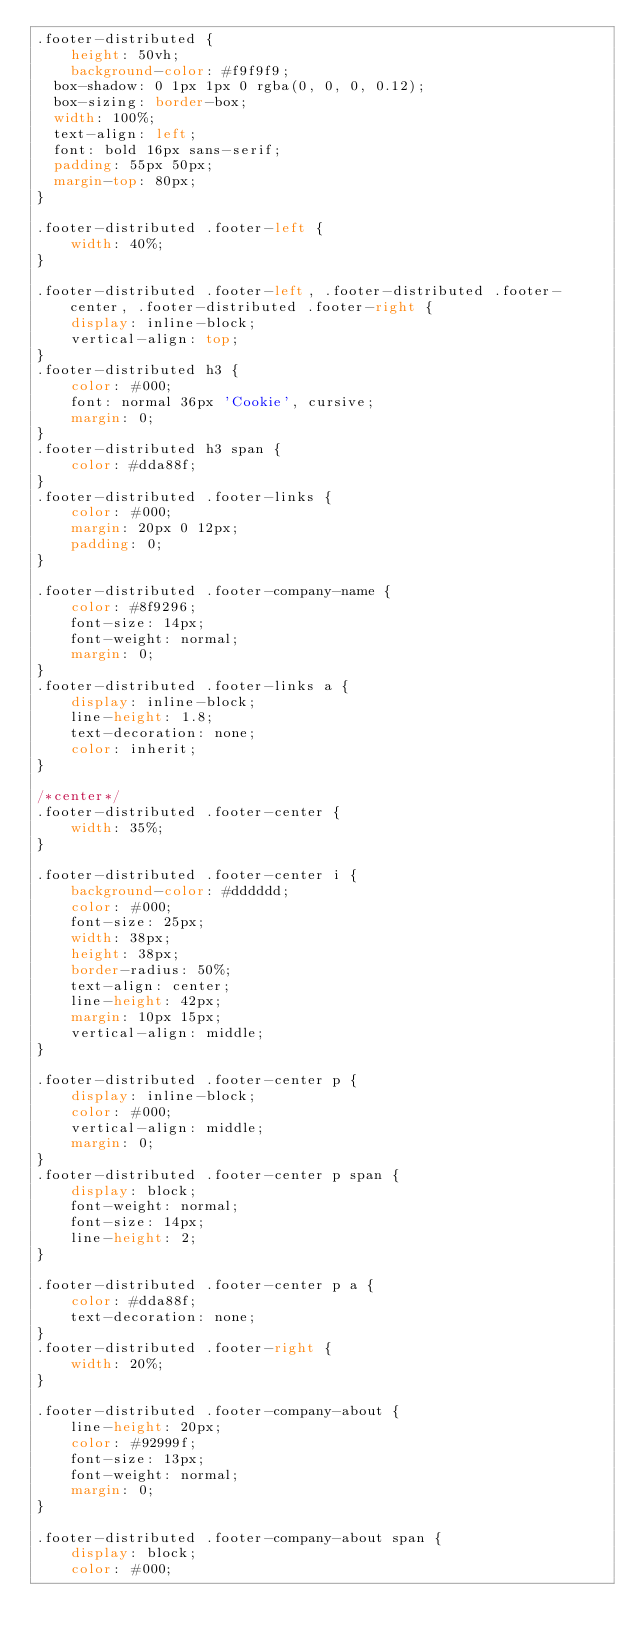<code> <loc_0><loc_0><loc_500><loc_500><_CSS_>.footer-distributed {
	height: 50vh;
	background-color: #f9f9f9;
  box-shadow: 0 1px 1px 0 rgba(0, 0, 0, 0.12);
  box-sizing: border-box;
  width: 100%;
  text-align: left;
  font: bold 16px sans-serif;
  padding: 55px 50px;
  margin-top: 80px;
}

.footer-distributed .footer-left {
    width: 40%;
}

.footer-distributed .footer-left, .footer-distributed .footer-center, .footer-distributed .footer-right {
    display: inline-block;
    vertical-align: top;
}
.footer-distributed h3 {
    color: #000;
    font: normal 36px 'Cookie', cursive;
    margin: 0;
}
.footer-distributed h3 span {
    color: #dda88f;
}
.footer-distributed .footer-links {
    color: #000;
    margin: 20px 0 12px;
    padding: 0;
}

.footer-distributed .footer-company-name {
    color: #8f9296;
    font-size: 14px;
    font-weight: normal;
    margin: 0;
}
.footer-distributed .footer-links a {
    display: inline-block;
    line-height: 1.8;
    text-decoration: none;
    color: inherit;
}

/*center*/
.footer-distributed .footer-center {
    width: 35%;
}

.footer-distributed .footer-center i {
    background-color: #dddddd;
    color: #000;
    font-size: 25px;
    width: 38px;
    height: 38px;
    border-radius: 50%;
    text-align: center;
    line-height: 42px;
    margin: 10px 15px;
    vertical-align: middle;
}

.footer-distributed .footer-center p {
    display: inline-block;
    color: #000;
    vertical-align: middle;
    margin: 0;
}
.footer-distributed .footer-center p span {
    display: block;
    font-weight: normal;
    font-size: 14px;
    line-height: 2;
}

.footer-distributed .footer-center p a {
    color: #dda88f;
    text-decoration: none;
}
.footer-distributed .footer-right {
    width: 20%;
}

.footer-distributed .footer-company-about {
    line-height: 20px;
    color: #92999f;
    font-size: 13px;
    font-weight: normal;
    margin: 0;
}

.footer-distributed .footer-company-about span {
    display: block;
    color: #000;</code> 